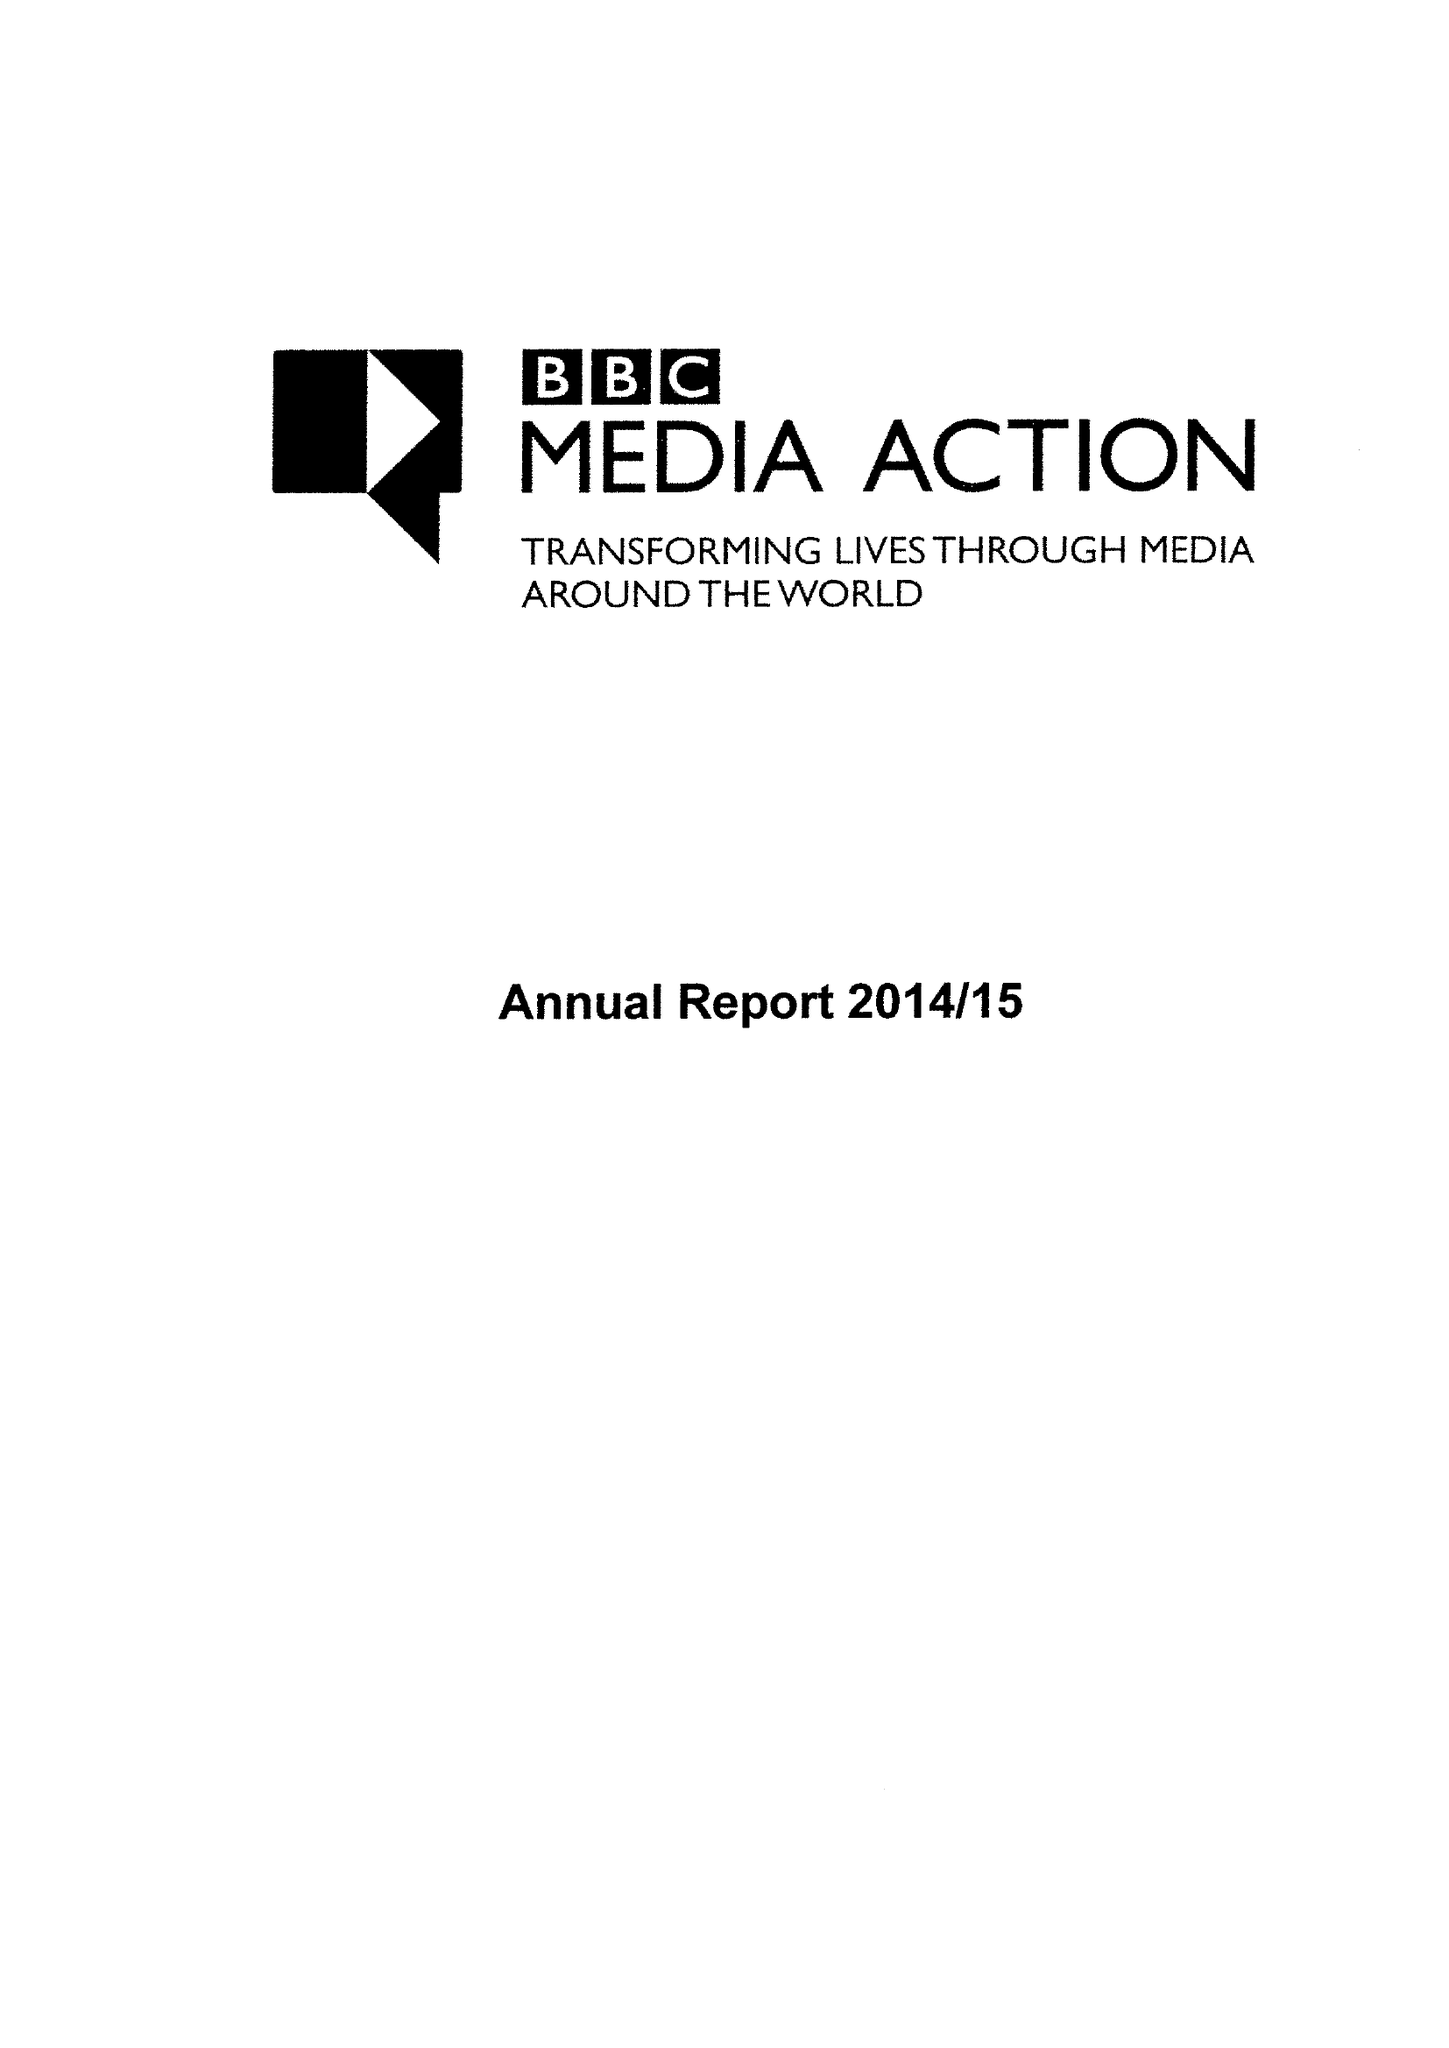What is the value for the charity_number?
Answer the question using a single word or phrase. 1076235 